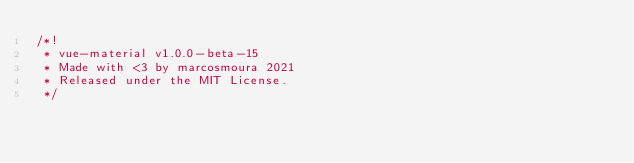Convert code to text. <code><loc_0><loc_0><loc_500><loc_500><_CSS_>/*!
 * vue-material v1.0.0-beta-15
 * Made with <3 by marcosmoura 2021
 * Released under the MIT License.
 */</code> 